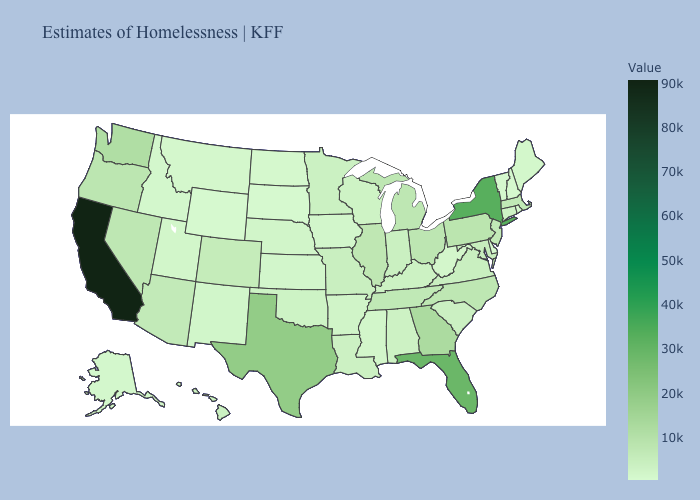Does Hawaii have a lower value than Florida?
Be succinct. Yes. Does Maryland have the highest value in the USA?
Concise answer only. No. Is the legend a continuous bar?
Be succinct. Yes. Does Rhode Island have the lowest value in the Northeast?
Write a very short answer. Yes. Among the states that border Oregon , does Washington have the lowest value?
Short answer required. No. Does the map have missing data?
Give a very brief answer. No. Does Montana have the highest value in the USA?
Answer briefly. No. 